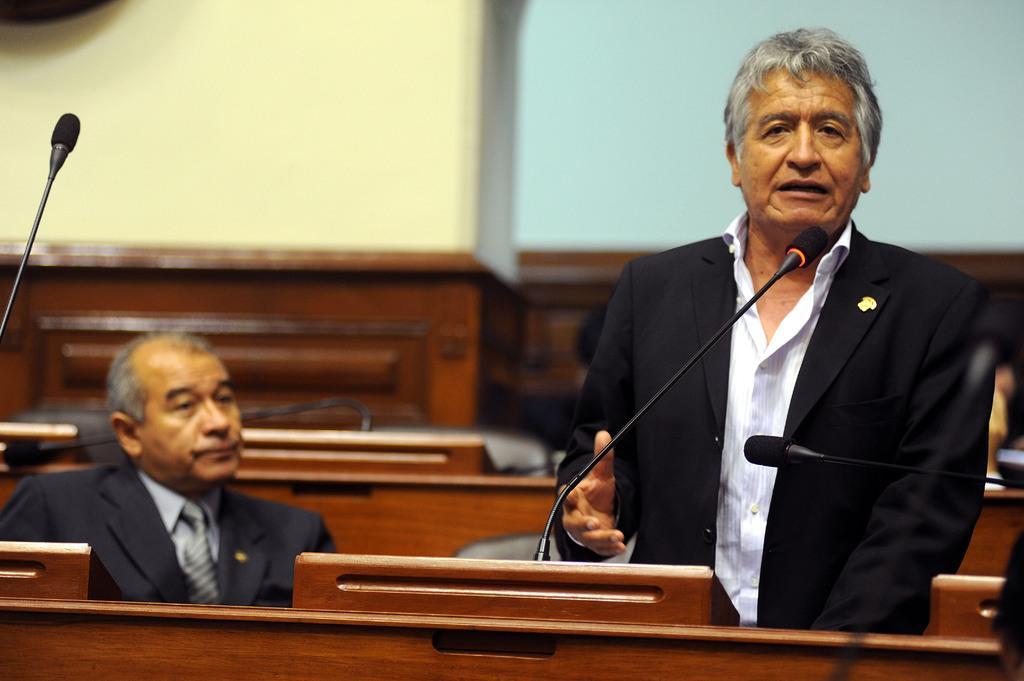How would you summarize this image in a sentence or two? In the picture I can see a person wearing black jacket is standing and speaking in front of a mic in the right corner and there is another person sitting beside him and there are few chairs and a table in the background. 